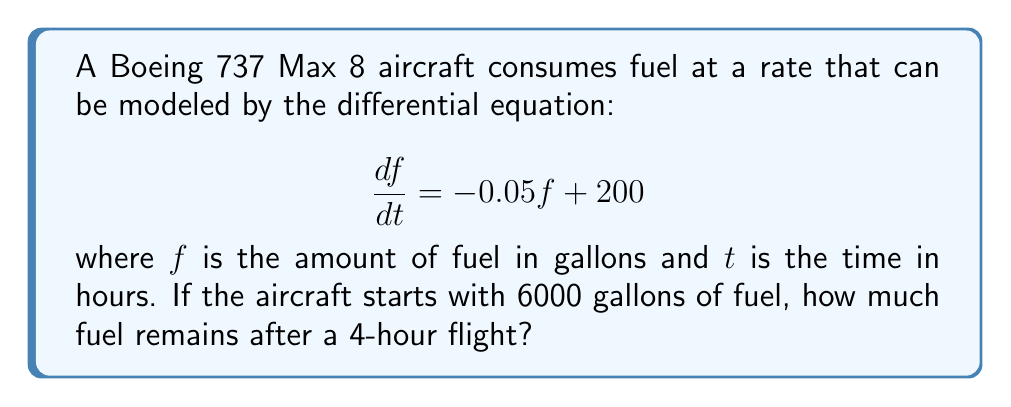Solve this math problem. To solve this problem, we need to follow these steps:

1) The given differential equation is of the form:
   $$\frac{df}{dt} + 0.05f = 200$$

2) This is a first-order linear differential equation. The general solution is:
   $$f(t) = Ce^{-0.05t} + 4000$$
   where $C$ is a constant to be determined from the initial condition.

3) Using the initial condition $f(0) = 6000$, we can find $C$:
   $$6000 = C + 4000$$
   $$C = 2000$$

4) Therefore, the particular solution is:
   $$f(t) = 2000e^{-0.05t} + 4000$$

5) To find the amount of fuel after 4 hours, we evaluate $f(4)$:
   $$f(4) = 2000e^{-0.05(4)} + 4000$$
   $$f(4) = 2000e^{-0.2} + 4000$$
   $$f(4) = 2000(0.8187) + 4000$$
   $$f(4) = 1637.4 + 4000 = 5637.4$$

6) Rounding to the nearest gallon:
   $$f(4) \approx 5637 \text{ gallons}$$
Answer: 5637 gallons 